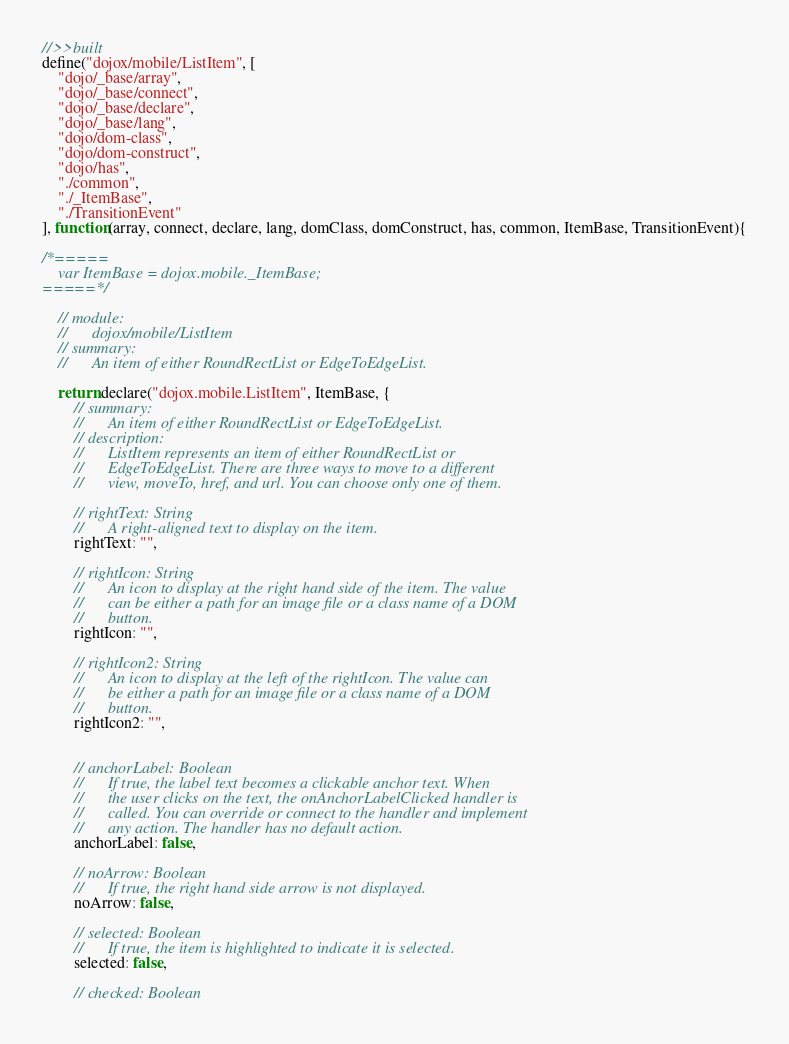<code> <loc_0><loc_0><loc_500><loc_500><_JavaScript_>//>>built
define("dojox/mobile/ListItem", [
	"dojo/_base/array",
	"dojo/_base/connect",
	"dojo/_base/declare",
	"dojo/_base/lang",
	"dojo/dom-class",
	"dojo/dom-construct",
	"dojo/has",
	"./common",
	"./_ItemBase",
	"./TransitionEvent"
], function(array, connect, declare, lang, domClass, domConstruct, has, common, ItemBase, TransitionEvent){

/*=====
	var ItemBase = dojox.mobile._ItemBase;
=====*/

	// module:
	//		dojox/mobile/ListItem
	// summary:
	//		An item of either RoundRectList or EdgeToEdgeList.

	return declare("dojox.mobile.ListItem", ItemBase, {
		// summary:
		//		An item of either RoundRectList or EdgeToEdgeList.
		// description:
		//		ListItem represents an item of either RoundRectList or
		//		EdgeToEdgeList. There are three ways to move to a different
		//		view, moveTo, href, and url. You can choose only one of them.

		// rightText: String
		//		A right-aligned text to display on the item.
		rightText: "",

		// rightIcon: String
		//		An icon to display at the right hand side of the item. The value
		//		can be either a path for an image file or a class name of a DOM
		//		button.
		rightIcon: "",

		// rightIcon2: String
		//		An icon to display at the left of the rightIcon. The value can
		//		be either a path for an image file or a class name of a DOM
		//		button.
		rightIcon2: "",


		// anchorLabel: Boolean
		//		If true, the label text becomes a clickable anchor text. When
		//		the user clicks on the text, the onAnchorLabelClicked handler is
		//		called. You can override or connect to the handler and implement
		//		any action. The handler has no default action.
		anchorLabel: false,

		// noArrow: Boolean
		//		If true, the right hand side arrow is not displayed.
		noArrow: false,

		// selected: Boolean
		//		If true, the item is highlighted to indicate it is selected.
		selected: false,

		// checked: Boolean</code> 